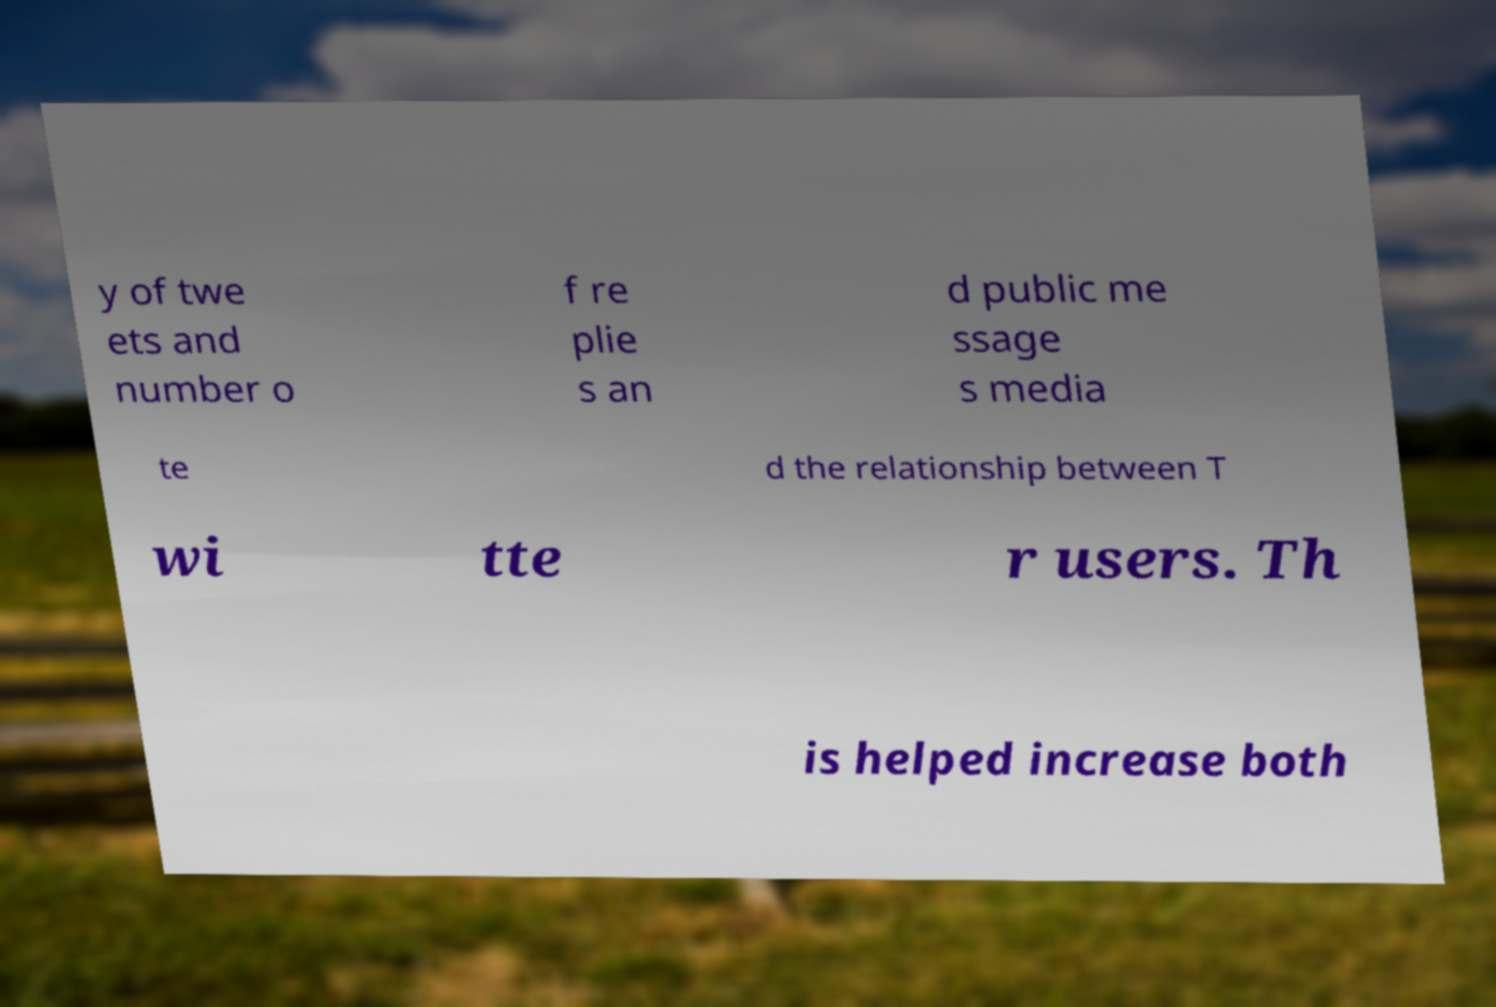I need the written content from this picture converted into text. Can you do that? y of twe ets and number o f re plie s an d public me ssage s media te d the relationship between T wi tte r users. Th is helped increase both 